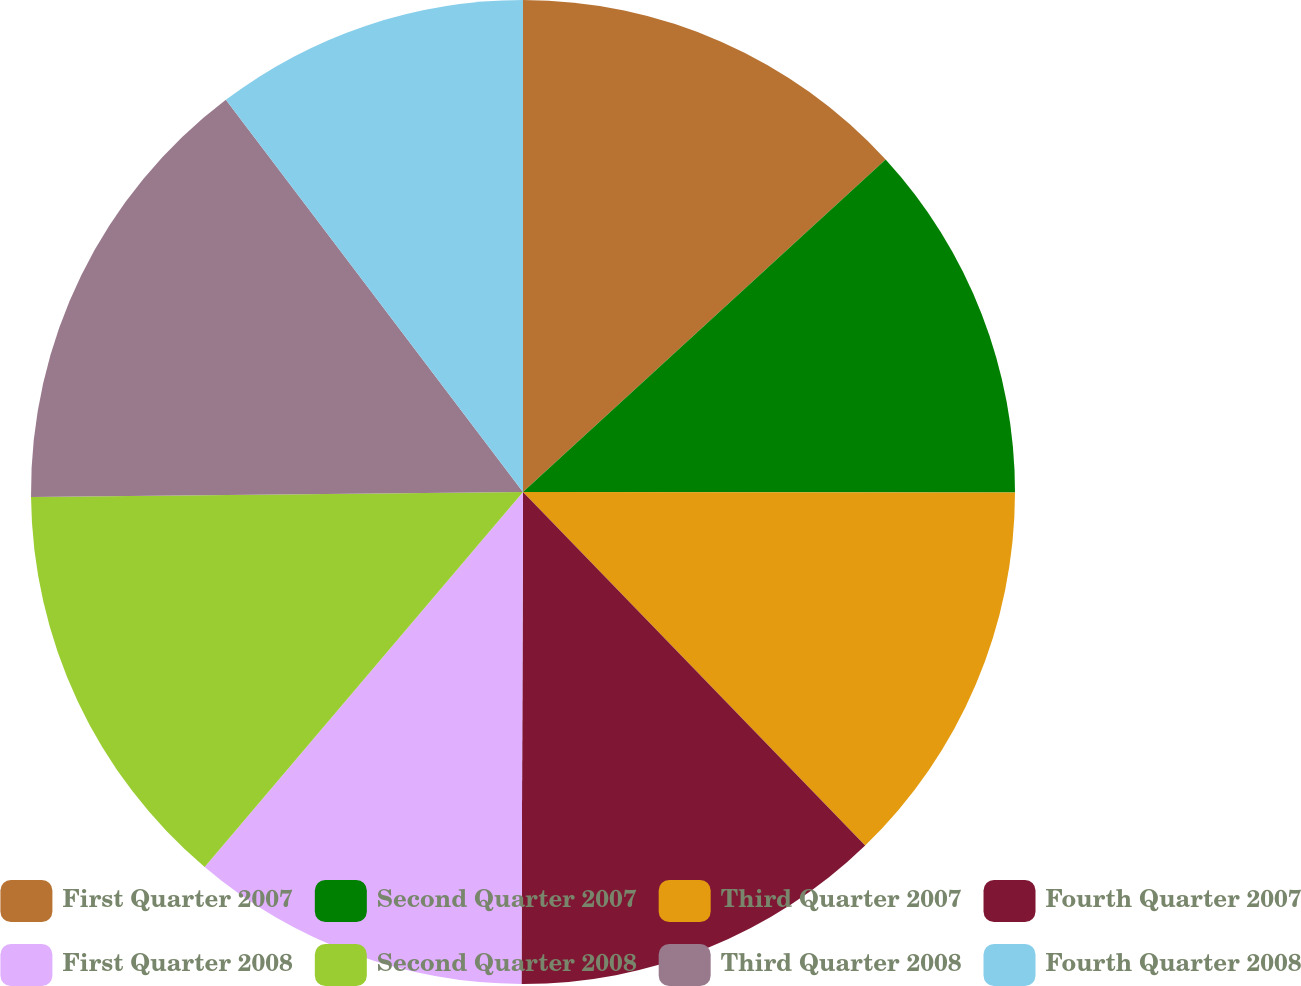Convert chart to OTSL. <chart><loc_0><loc_0><loc_500><loc_500><pie_chart><fcel>First Quarter 2007<fcel>Second Quarter 2007<fcel>Third Quarter 2007<fcel>Fourth Quarter 2007<fcel>First Quarter 2008<fcel>Second Quarter 2008<fcel>Third Quarter 2008<fcel>Fourth Quarter 2008<nl><fcel>13.19%<fcel>11.83%<fcel>12.74%<fcel>12.29%<fcel>11.15%<fcel>13.64%<fcel>14.84%<fcel>10.32%<nl></chart> 